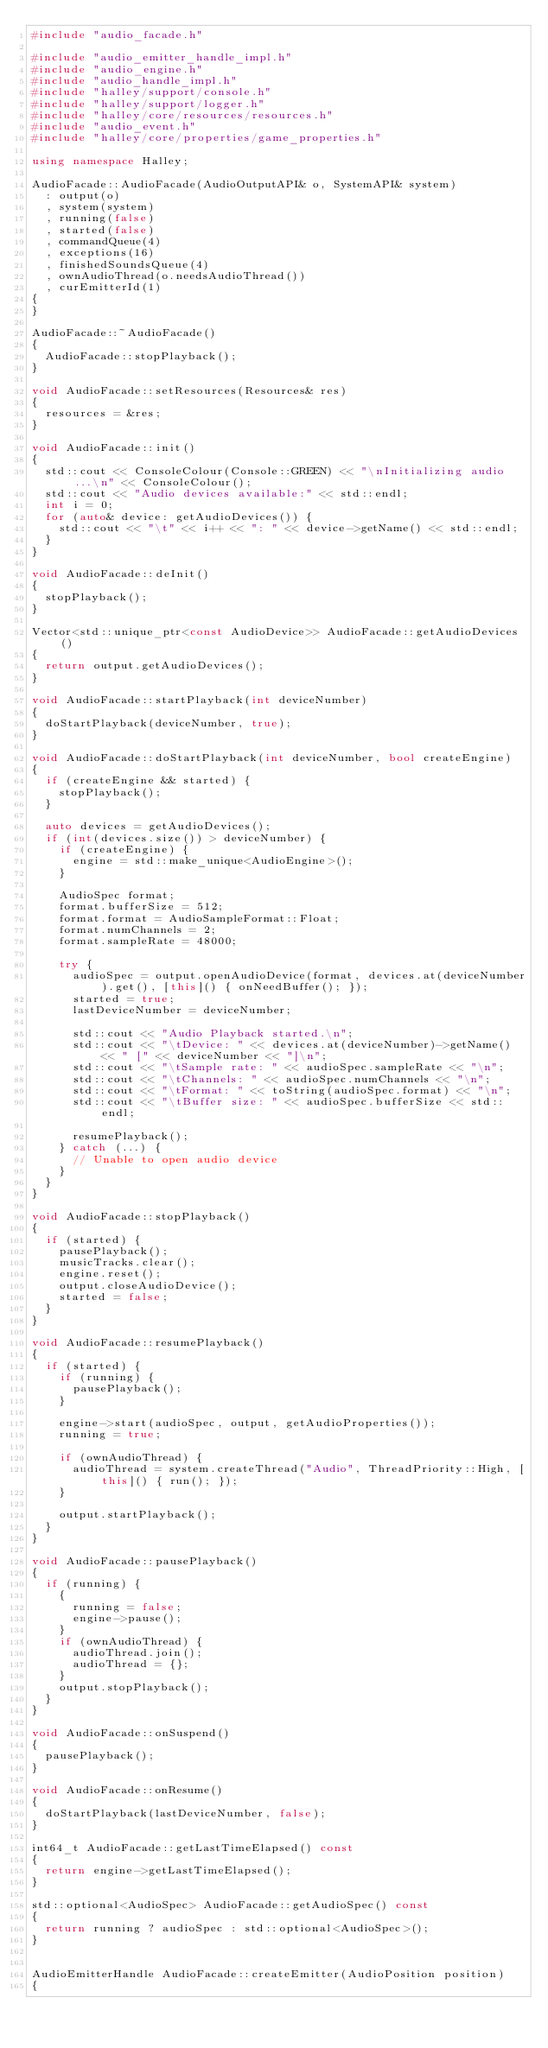<code> <loc_0><loc_0><loc_500><loc_500><_C++_>#include "audio_facade.h"

#include "audio_emitter_handle_impl.h"
#include "audio_engine.h"
#include "audio_handle_impl.h"
#include "halley/support/console.h"
#include "halley/support/logger.h"
#include "halley/core/resources/resources.h"
#include "audio_event.h"
#include "halley/core/properties/game_properties.h"

using namespace Halley;

AudioFacade::AudioFacade(AudioOutputAPI& o, SystemAPI& system)
	: output(o)
	, system(system)
	, running(false)
	, started(false)
	, commandQueue(4)
	, exceptions(16)
	, finishedSoundsQueue(4)
	, ownAudioThread(o.needsAudioThread())
	, curEmitterId(1)
{
}

AudioFacade::~AudioFacade()
{
	AudioFacade::stopPlayback();
}

void AudioFacade::setResources(Resources& res)
{
	resources = &res;
}

void AudioFacade::init()
{
	std::cout << ConsoleColour(Console::GREEN) << "\nInitializing audio...\n" << ConsoleColour();
	std::cout << "Audio devices available:" << std::endl;
	int i = 0;
	for (auto& device: getAudioDevices()) {
		std::cout << "\t" << i++ << ": " << device->getName() << std::endl;
	}
}

void AudioFacade::deInit()
{
	stopPlayback();
}

Vector<std::unique_ptr<const AudioDevice>> AudioFacade::getAudioDevices()
{
	return output.getAudioDevices();
}

void AudioFacade::startPlayback(int deviceNumber)
{
	doStartPlayback(deviceNumber, true);
}

void AudioFacade::doStartPlayback(int deviceNumber, bool createEngine)
{
	if (createEngine && started) {
		stopPlayback();
	}

	auto devices = getAudioDevices();
	if (int(devices.size()) > deviceNumber) {
		if (createEngine) {
			engine = std::make_unique<AudioEngine>();
		}

		AudioSpec format;
		format.bufferSize = 512;
		format.format = AudioSampleFormat::Float;
		format.numChannels = 2;
		format.sampleRate = 48000;

		try {
			audioSpec = output.openAudioDevice(format, devices.at(deviceNumber).get(), [this]() { onNeedBuffer(); });
			started = true;
			lastDeviceNumber = deviceNumber;

			std::cout << "Audio Playback started.\n";
			std::cout << "\tDevice: " << devices.at(deviceNumber)->getName() << " [" << deviceNumber << "]\n";
			std::cout << "\tSample rate: " << audioSpec.sampleRate << "\n";
			std::cout << "\tChannels: " << audioSpec.numChannels << "\n";
			std::cout << "\tFormat: " << toString(audioSpec.format) << "\n";
			std::cout << "\tBuffer size: " << audioSpec.bufferSize << std::endl;

			resumePlayback();
		} catch (...) {
			// Unable to open audio device
		}
	}
}

void AudioFacade::stopPlayback()
{
	if (started) {
		pausePlayback();
		musicTracks.clear();
		engine.reset();
		output.closeAudioDevice();
		started = false;
	}
}

void AudioFacade::resumePlayback()
{
	if (started) {
		if (running) {
			pausePlayback();
		}

		engine->start(audioSpec, output, getAudioProperties());
		running = true;

		if (ownAudioThread) {
			audioThread = system.createThread("Audio", ThreadPriority::High, [this]() { run(); });
		}

		output.startPlayback();
	}
}

void AudioFacade::pausePlayback()
{
	if (running) {
		{
			running = false;
			engine->pause();
		}
		if (ownAudioThread) {
			audioThread.join();
			audioThread = {};
		}
		output.stopPlayback();
	}
}

void AudioFacade::onSuspend()
{
	pausePlayback();
}

void AudioFacade::onResume()
{
	doStartPlayback(lastDeviceNumber, false);
}

int64_t AudioFacade::getLastTimeElapsed() const
{
	return engine->getLastTimeElapsed();
}

std::optional<AudioSpec> AudioFacade::getAudioSpec() const
{
	return running ? audioSpec : std::optional<AudioSpec>();
}


AudioEmitterHandle AudioFacade::createEmitter(AudioPosition position)
{</code> 